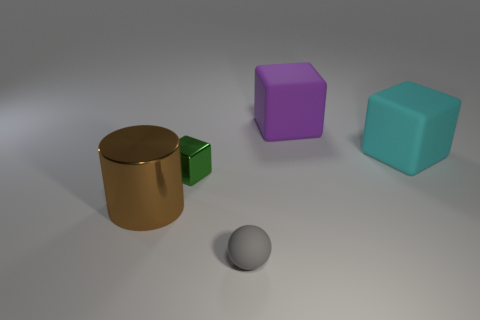Subtract all large matte cubes. How many cubes are left? 1 Subtract 1 cubes. How many cubes are left? 2 Add 5 gray matte spheres. How many objects exist? 10 Subtract all yellow blocks. Subtract all blue cylinders. How many blocks are left? 3 Subtract all spheres. How many objects are left? 4 Add 4 big matte things. How many big matte things exist? 6 Subtract 1 gray balls. How many objects are left? 4 Subtract all tiny spheres. Subtract all large shiny things. How many objects are left? 3 Add 5 small rubber objects. How many small rubber objects are left? 6 